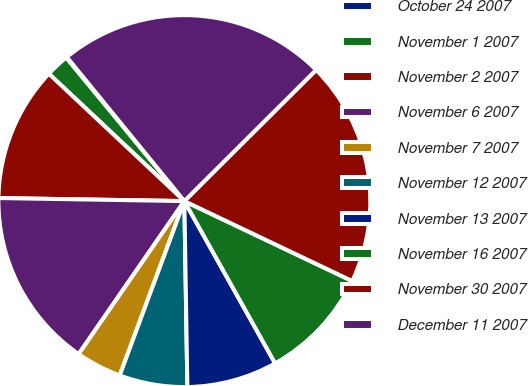Convert chart to OTSL. <chart><loc_0><loc_0><loc_500><loc_500><pie_chart><fcel>October 24 2007<fcel>November 1 2007<fcel>November 2 2007<fcel>November 6 2007<fcel>November 7 2007<fcel>November 12 2007<fcel>November 13 2007<fcel>November 16 2007<fcel>November 30 2007<fcel>December 11 2007<nl><fcel>0.08%<fcel>2.02%<fcel>11.75%<fcel>15.64%<fcel>3.97%<fcel>5.91%<fcel>7.86%<fcel>9.81%<fcel>19.54%<fcel>23.43%<nl></chart> 